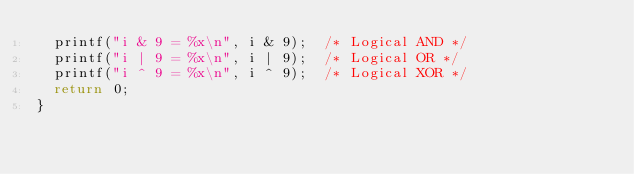<code> <loc_0><loc_0><loc_500><loc_500><_C_>  printf("i & 9 = %x\n", i & 9);  /* Logical AND */
  printf("i | 9 = %x\n", i | 9);  /* Logical OR */
  printf("i ^ 9 = %x\n", i ^ 9);  /* Logical XOR */
  return 0;
}
</code> 